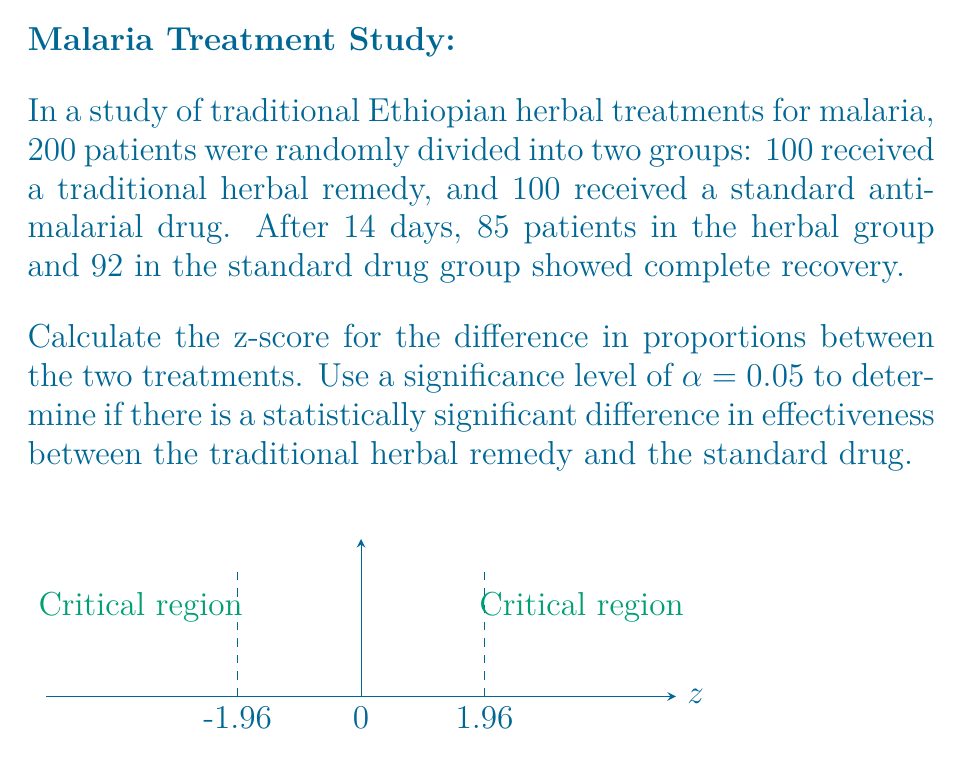Can you solve this math problem? Let's approach this step-by-step:

1) First, we need to calculate the proportions for each group:
   
   Herbal group: $p_1 = 85/100 = 0.85$
   Standard drug group: $p_2 = 92/100 = 0.92$

2) The difference in proportions is:
   $\hat{p_1} - \hat{p_2} = 0.85 - 0.92 = -0.07$

3) To calculate the z-score, we use the formula:

   $z = \frac{\hat{p_1} - \hat{p_2}}{\sqrt{\hat{p}(1-\hat{p})(\frac{1}{n_1} + \frac{1}{n_2})}}$

   Where $\hat{p}$ is the pooled proportion: $\hat{p} = \frac{X_1 + X_2}{n_1 + n_2}$

4) Calculate the pooled proportion:
   $\hat{p} = \frac{85 + 92}{100 + 100} = \frac{177}{200} = 0.885$

5) Now we can calculate the denominator of the z-score formula:
   $\sqrt{0.885(1-0.885)(\frac{1}{100} + \frac{1}{100})} = \sqrt{0.885 * 0.115 * 0.02} = 0.0451$

6) Finally, we can calculate the z-score:
   $z = \frac{-0.07}{0.0451} = -1.55$

7) To determine statistical significance, we compare this to the critical z-value for α = 0.05 (two-tailed test), which is ±1.96.

   Since |-1.55| < 1.96, we fail to reject the null hypothesis.
Answer: z = -1.55; Not statistically significant at α = 0.05 